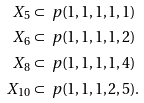<formula> <loc_0><loc_0><loc_500><loc_500>X _ { 5 } & \subset \ p ( 1 , 1 , 1 , 1 , 1 ) \\ X _ { 6 } & \subset \ p ( 1 , 1 , 1 , 1 , 2 ) \\ X _ { 8 } & \subset \ p ( 1 , 1 , 1 , 1 , 4 ) \\ X _ { 1 0 } & \subset \ p ( 1 , 1 , 1 , 2 , 5 ) .</formula> 